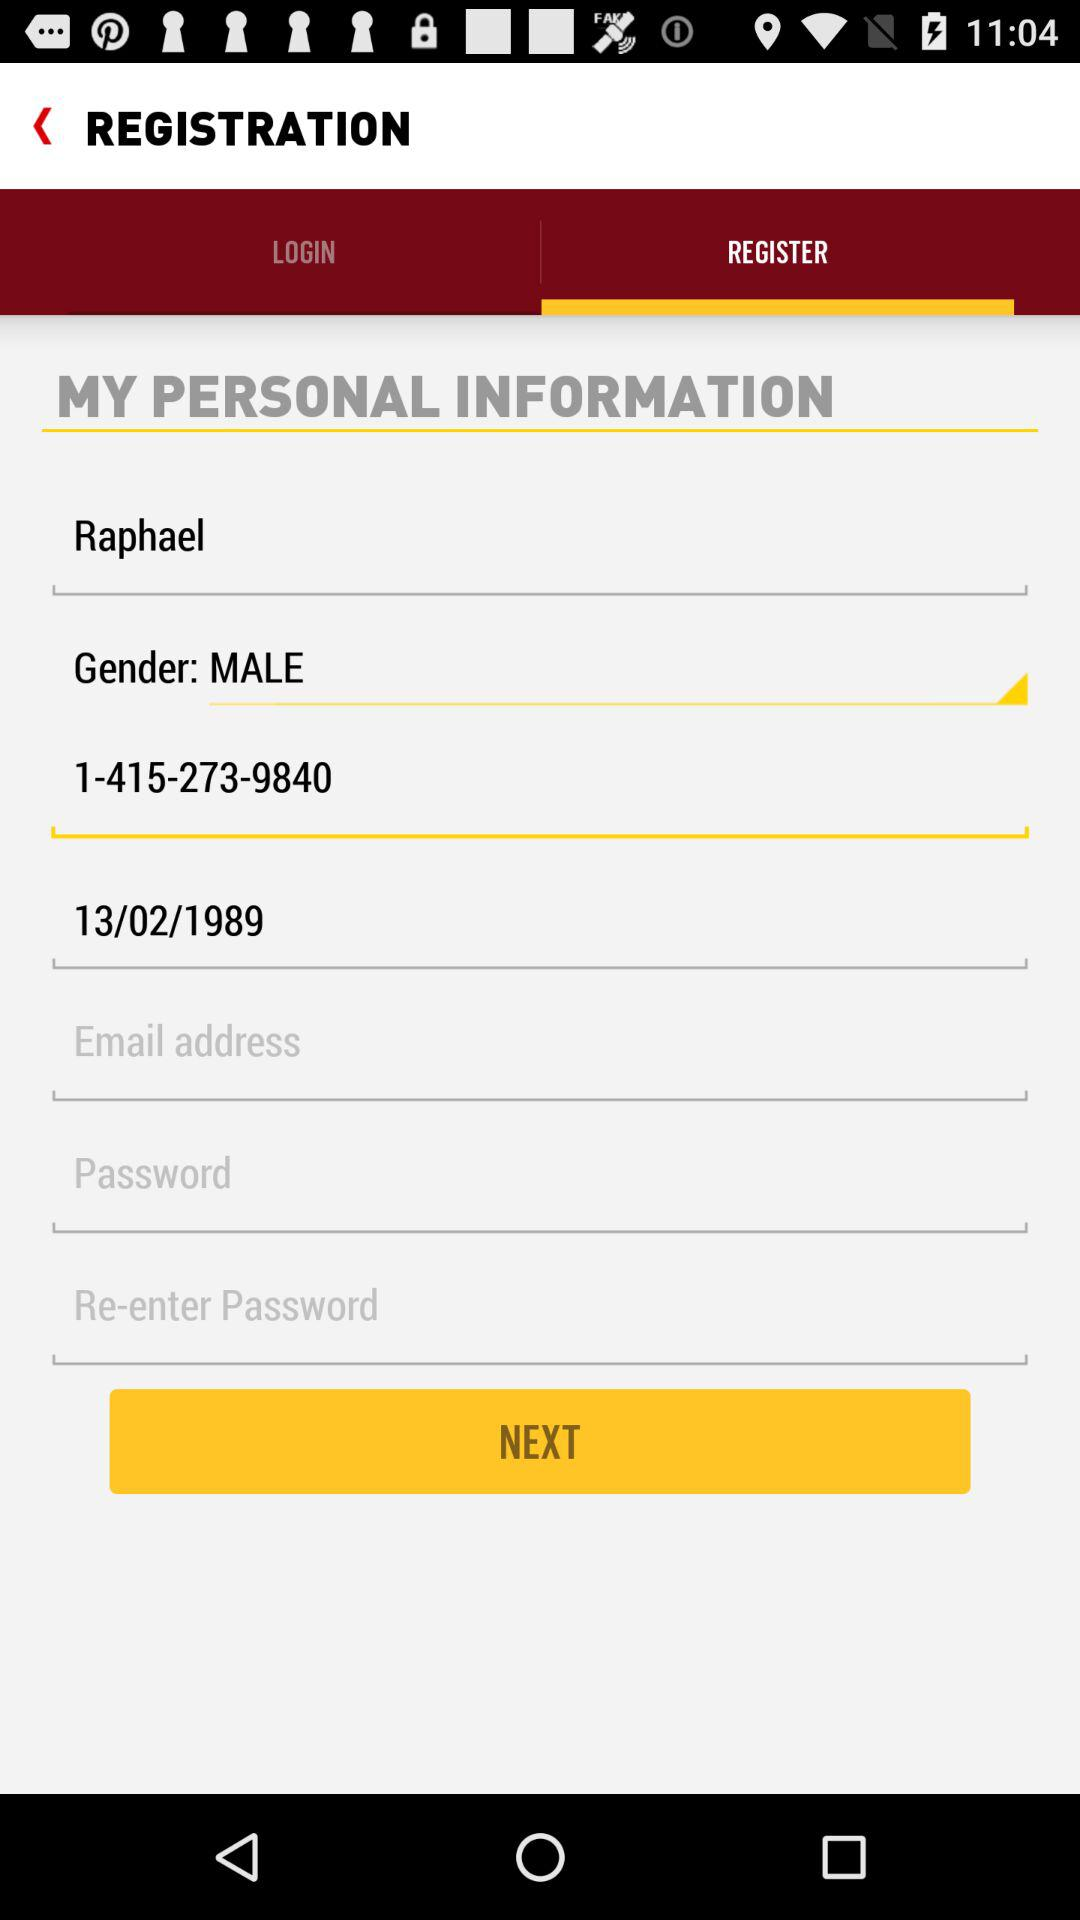Which option was selected for the registration? The selected option was "REGISTER". 